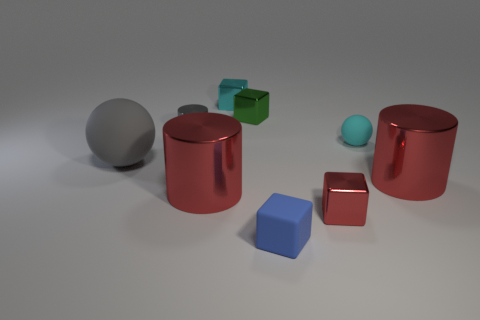Subtract all tiny cyan cubes. How many cubes are left? 3 Subtract 3 blocks. How many blocks are left? 1 Add 1 purple metal spheres. How many objects exist? 10 Subtract all gray cylinders. How many cylinders are left? 2 Subtract 0 brown cylinders. How many objects are left? 9 Subtract all blocks. How many objects are left? 5 Subtract all green cylinders. Subtract all gray spheres. How many cylinders are left? 3 Subtract all green balls. How many blue blocks are left? 1 Subtract all small metallic cylinders. Subtract all big gray objects. How many objects are left? 7 Add 3 cyan spheres. How many cyan spheres are left? 4 